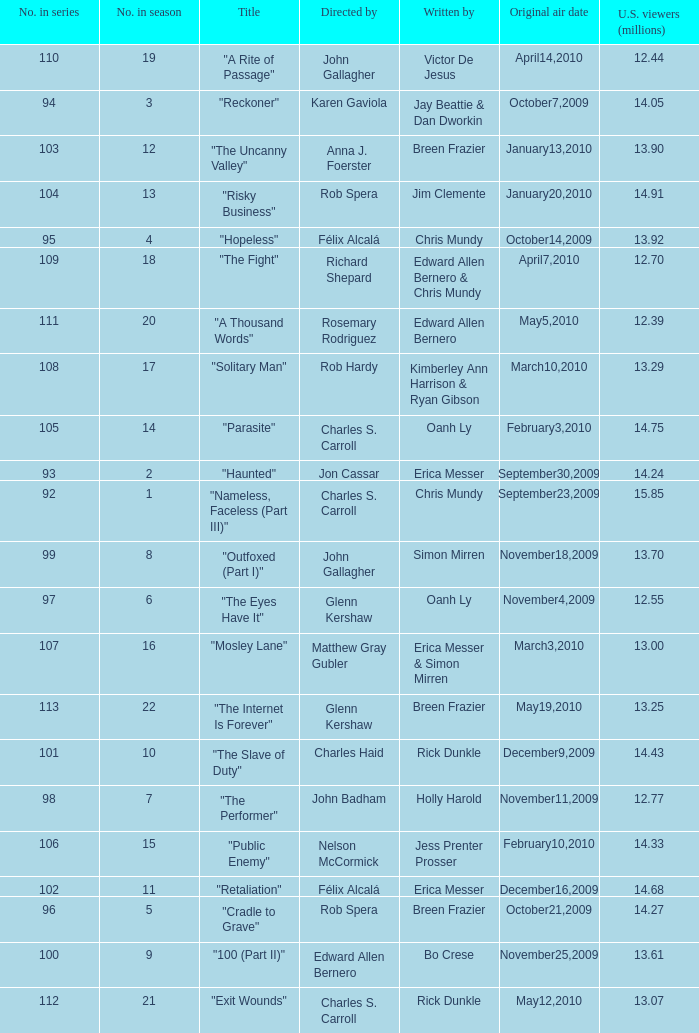Would you mind parsing the complete table? {'header': ['No. in series', 'No. in season', 'Title', 'Directed by', 'Written by', 'Original air date', 'U.S. viewers (millions)'], 'rows': [['110', '19', '"A Rite of Passage"', 'John Gallagher', 'Victor De Jesus', 'April14,2010', '12.44'], ['94', '3', '"Reckoner"', 'Karen Gaviola', 'Jay Beattie & Dan Dworkin', 'October7,2009', '14.05'], ['103', '12', '"The Uncanny Valley"', 'Anna J. Foerster', 'Breen Frazier', 'January13,2010', '13.90'], ['104', '13', '"Risky Business"', 'Rob Spera', 'Jim Clemente', 'January20,2010', '14.91'], ['95', '4', '"Hopeless"', 'Félix Alcalá', 'Chris Mundy', 'October14,2009', '13.92'], ['109', '18', '"The Fight"', 'Richard Shepard', 'Edward Allen Bernero & Chris Mundy', 'April7,2010', '12.70'], ['111', '20', '"A Thousand Words"', 'Rosemary Rodriguez', 'Edward Allen Bernero', 'May5,2010', '12.39'], ['108', '17', '"Solitary Man"', 'Rob Hardy', 'Kimberley Ann Harrison & Ryan Gibson', 'March10,2010', '13.29'], ['105', '14', '"Parasite"', 'Charles S. Carroll', 'Oanh Ly', 'February3,2010', '14.75'], ['93', '2', '"Haunted"', 'Jon Cassar', 'Erica Messer', 'September30,2009', '14.24'], ['92', '1', '"Nameless, Faceless (Part III)"', 'Charles S. Carroll', 'Chris Mundy', 'September23,2009', '15.85'], ['99', '8', '"Outfoxed (Part I)"', 'John Gallagher', 'Simon Mirren', 'November18,2009', '13.70'], ['97', '6', '"The Eyes Have It"', 'Glenn Kershaw', 'Oanh Ly', 'November4,2009', '12.55'], ['107', '16', '"Mosley Lane"', 'Matthew Gray Gubler', 'Erica Messer & Simon Mirren', 'March3,2010', '13.00'], ['113', '22', '"The Internet Is Forever"', 'Glenn Kershaw', 'Breen Frazier', 'May19,2010', '13.25'], ['101', '10', '"The Slave of Duty"', 'Charles Haid', 'Rick Dunkle', 'December9,2009', '14.43'], ['98', '7', '"The Performer"', 'John Badham', 'Holly Harold', 'November11,2009', '12.77'], ['106', '15', '"Public Enemy"', 'Nelson McCormick', 'Jess Prenter Prosser', 'February10,2010', '14.33'], ['102', '11', '"Retaliation"', 'Félix Alcalá', 'Erica Messer', 'December16,2009', '14.68'], ['96', '5', '"Cradle to Grave"', 'Rob Spera', 'Breen Frazier', 'October21,2009', '14.27'], ['100', '9', '"100 (Part II)"', 'Edward Allen Bernero', 'Bo Crese', 'November25,2009', '13.61'], ['112', '21', '"Exit Wounds"', 'Charles S. Carroll', 'Rick Dunkle', 'May12,2010', '13.07']]} What season was the episode "haunted" in? 2.0. 